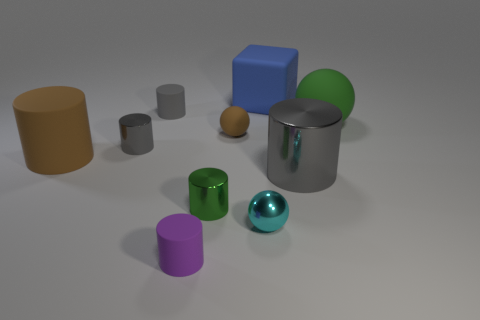Subtract all gray spheres. How many gray cylinders are left? 3 Subtract 3 cylinders. How many cylinders are left? 3 Subtract all brown cylinders. How many cylinders are left? 5 Subtract all big brown matte cylinders. How many cylinders are left? 5 Subtract all purple spheres. Subtract all purple cylinders. How many spheres are left? 3 Subtract all cylinders. How many objects are left? 4 Add 3 gray metal cylinders. How many gray metal cylinders exist? 5 Subtract 0 yellow cylinders. How many objects are left? 10 Subtract all big objects. Subtract all brown objects. How many objects are left? 4 Add 7 matte cubes. How many matte cubes are left? 8 